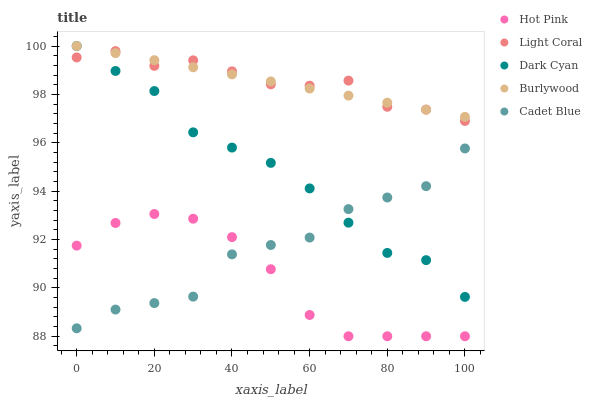Does Hot Pink have the minimum area under the curve?
Answer yes or no. Yes. Does Light Coral have the maximum area under the curve?
Answer yes or no. Yes. Does Dark Cyan have the minimum area under the curve?
Answer yes or no. No. Does Dark Cyan have the maximum area under the curve?
Answer yes or no. No. Is Burlywood the smoothest?
Answer yes or no. Yes. Is Cadet Blue the roughest?
Answer yes or no. Yes. Is Dark Cyan the smoothest?
Answer yes or no. No. Is Dark Cyan the roughest?
Answer yes or no. No. Does Hot Pink have the lowest value?
Answer yes or no. Yes. Does Dark Cyan have the lowest value?
Answer yes or no. No. Does Burlywood have the highest value?
Answer yes or no. Yes. Does Hot Pink have the highest value?
Answer yes or no. No. Is Hot Pink less than Light Coral?
Answer yes or no. Yes. Is Light Coral greater than Hot Pink?
Answer yes or no. Yes. Does Hot Pink intersect Cadet Blue?
Answer yes or no. Yes. Is Hot Pink less than Cadet Blue?
Answer yes or no. No. Is Hot Pink greater than Cadet Blue?
Answer yes or no. No. Does Hot Pink intersect Light Coral?
Answer yes or no. No. 